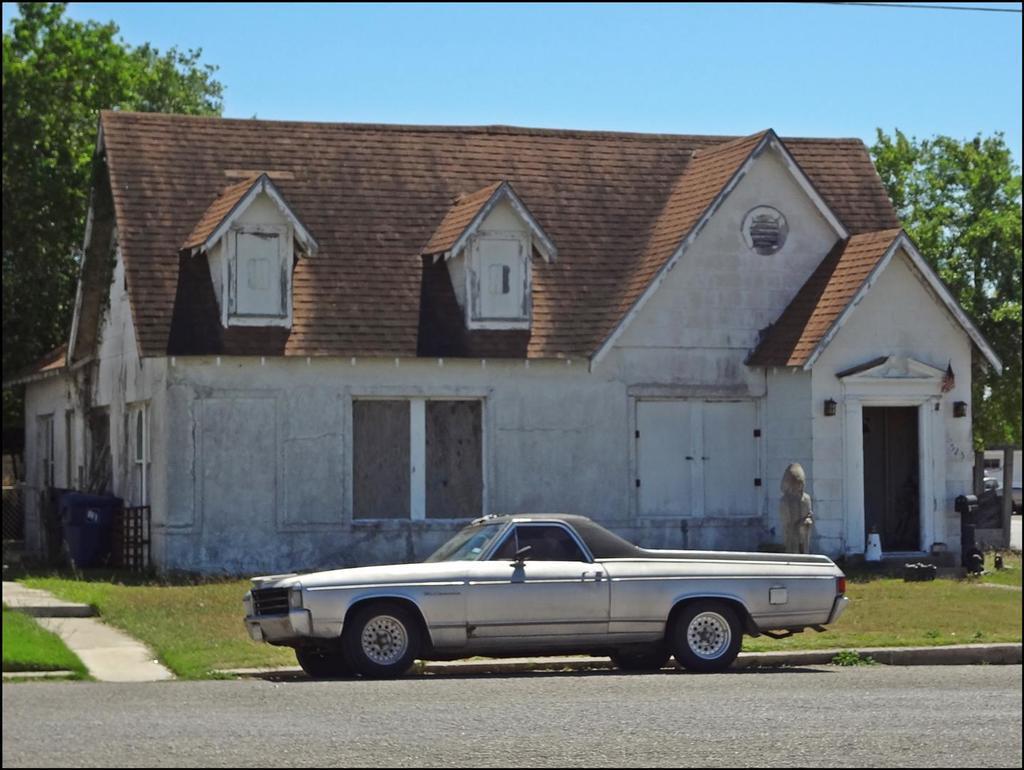Could you give a brief overview of what you see in this image? In the foreground of this image, there is a vehicle on the road. In the background, there is a house, trees, grassland and the sky. 